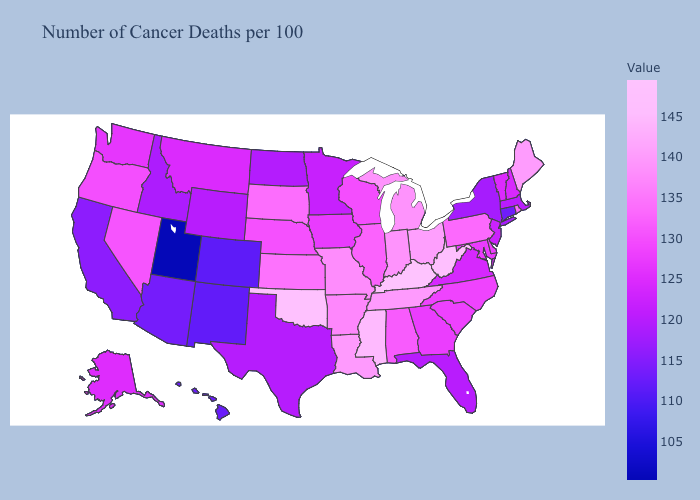Which states have the lowest value in the South?
Short answer required. Texas. Among the states that border Idaho , which have the highest value?
Answer briefly. Nevada. Among the states that border Massachusetts , does Vermont have the highest value?
Give a very brief answer. No. Among the states that border Wyoming , does Utah have the lowest value?
Answer briefly. Yes. Which states have the lowest value in the West?
Quick response, please. Utah. Which states have the lowest value in the MidWest?
Answer briefly. North Dakota. 